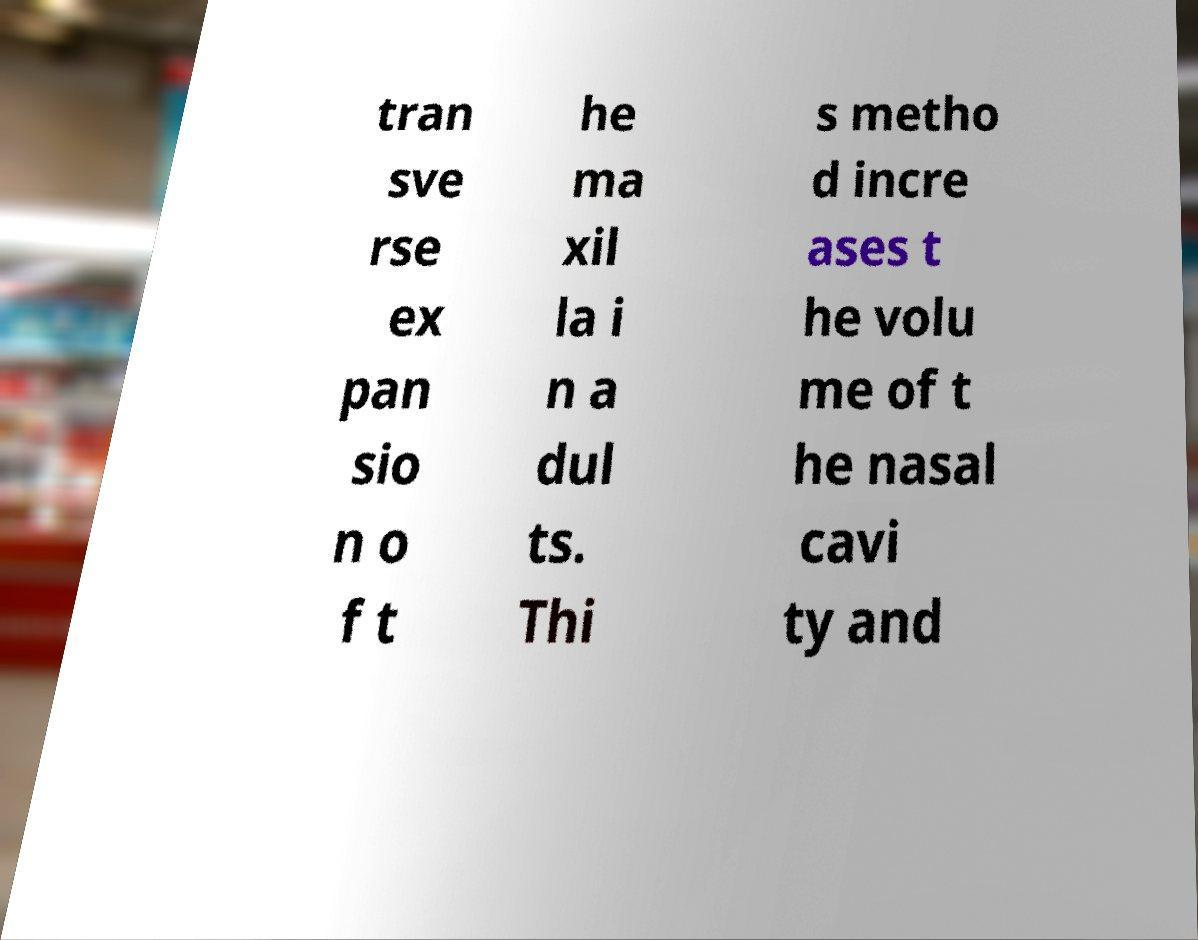There's text embedded in this image that I need extracted. Can you transcribe it verbatim? tran sve rse ex pan sio n o f t he ma xil la i n a dul ts. Thi s metho d incre ases t he volu me of t he nasal cavi ty and 